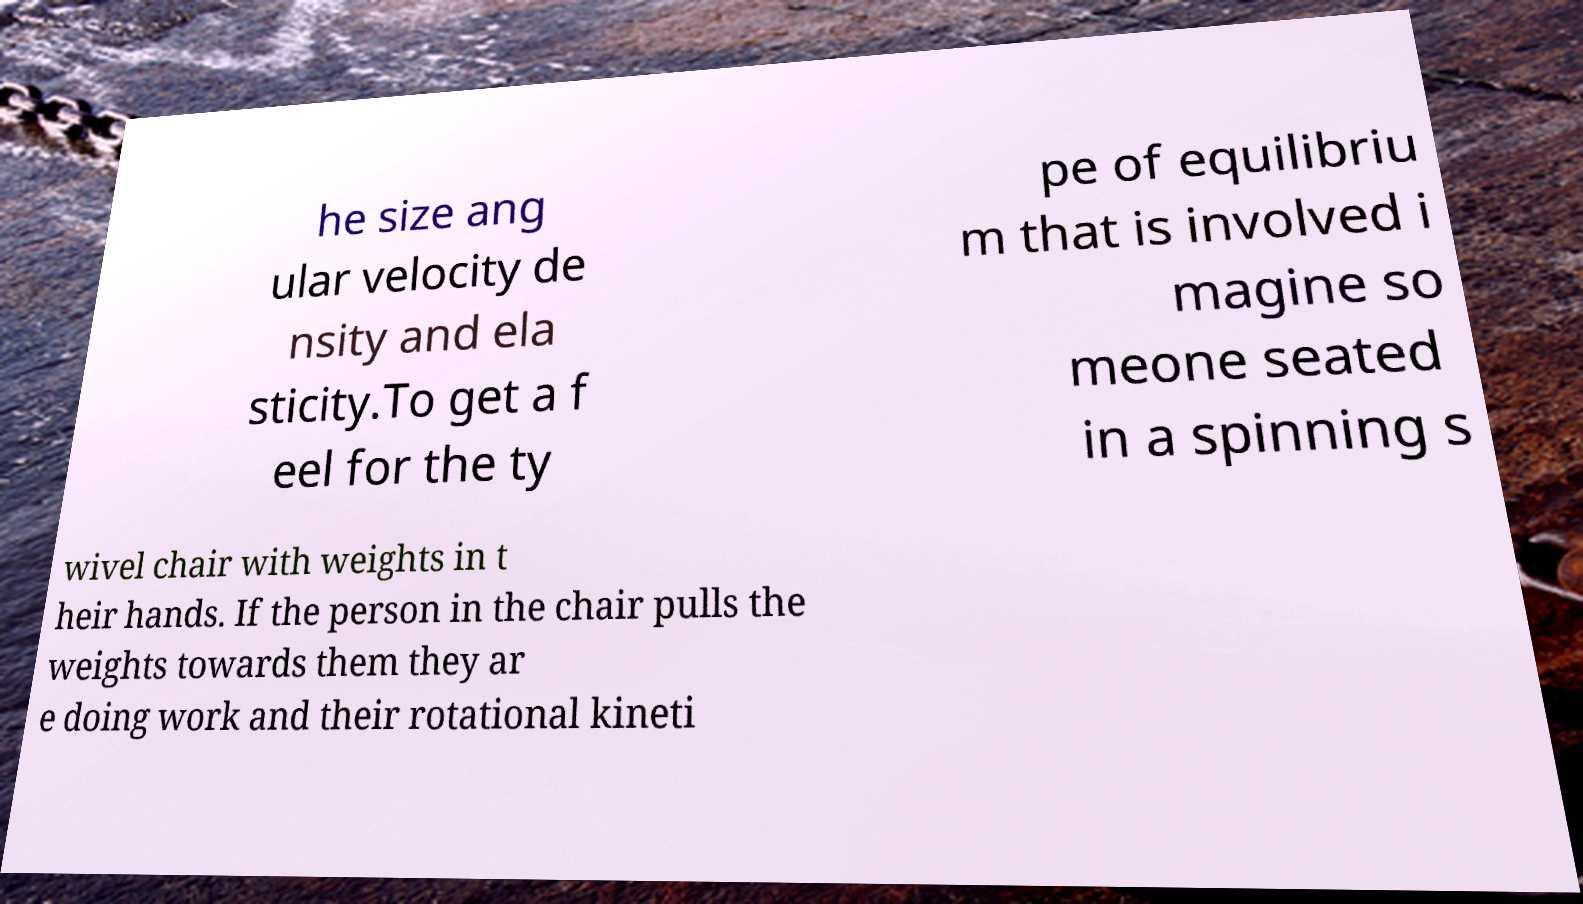Could you extract and type out the text from this image? he size ang ular velocity de nsity and ela sticity.To get a f eel for the ty pe of equilibriu m that is involved i magine so meone seated in a spinning s wivel chair with weights in t heir hands. If the person in the chair pulls the weights towards them they ar e doing work and their rotational kineti 